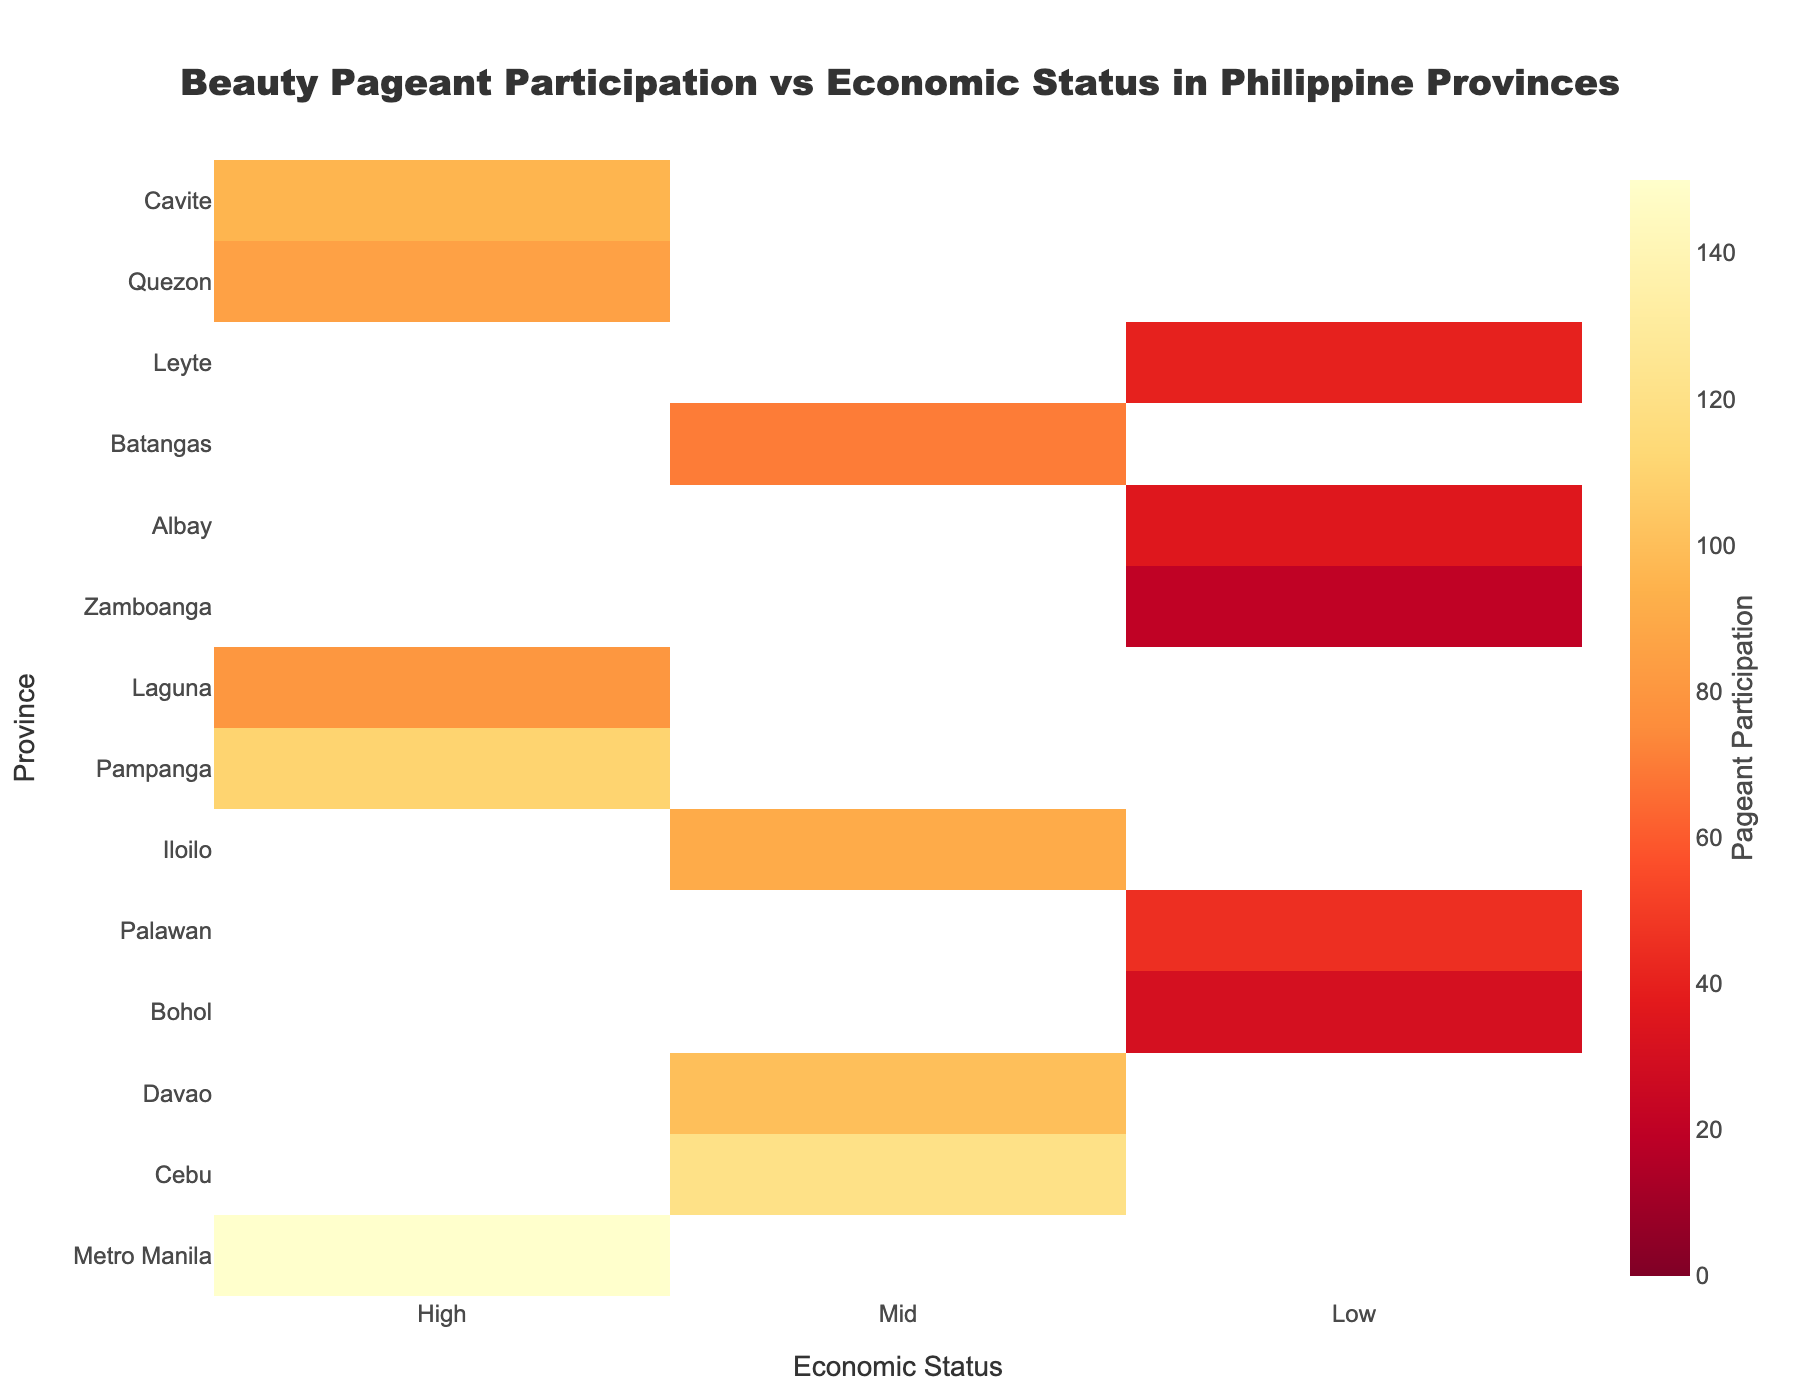Which province has the highest pageant participation? By looking at the color intensity on the heatmap, we observe that "Metro Manila" has the most intense color in the "High" economic status, indicating the highest participation.
Answer: Metro Manila What is the economic status of Zamboanga? Locate "Zamboanga" on the Y-axis, then check the corresponding X-axis value. The color code indicates a Low economic status.
Answer: Low Among the provinces with 'Low' economic status, which has the highest pageant participation? Identify provinces marked with a 'Low' status on the X-axis and compare the color intensities. "Palawan" has the most intense color.
Answer: Palawan How does pageant participation in Cebu compare with Bohol? Locate "Cebu" and "Bohol" on the Y-axis, and visually compare the color intensities. Cebu's intensity is higher, indicating more participation than Bohol.
Answer: Cebu has more participation What is the average pageant participation of provinces with 'Mid' economic status? Identify provinces with 'Mid' status: Cebu, Davao, Iloilo, Batangas. Sum their participation (120+100+90+70) = 380 and find the average: 380/4 = 95.
Answer: 95 Which province has the lowest pageant participation? Locate the province with the least intense color on the heatmap. "Zamboanga" in 'Low' status has the lowest intensity.
Answer: Zamboanga Is there any province with 'High' economic status and lower pageant participation than Batangas? Locate provinces with 'High' status and compare their participation with Batangas (Mid). Laguna with participation of 80 is lower than Batangas (70).
Answer: Yes, Laguna What is the total pageant participation of all provinces with 'High' economic status? Sum the participation values for provinces: Metro Manila, Pampanga, Laguna, Quezon, Cavite (150+110+80+85+95) = 520.
Answer: 520 Do any provinces have equal participation in beauty pageants? Compare the participation values of all provinces to find any duplicates. No two provinces have the same participation level.
Answer: No Which economic status shows the broadest range of pageant participation? Compare the range (difference between highest and lowest values) within each economic status class: High (150-80=70), Mid (120-70=50), Low (45-20=25). The High economic status shows the broadest range.
Answer: High 